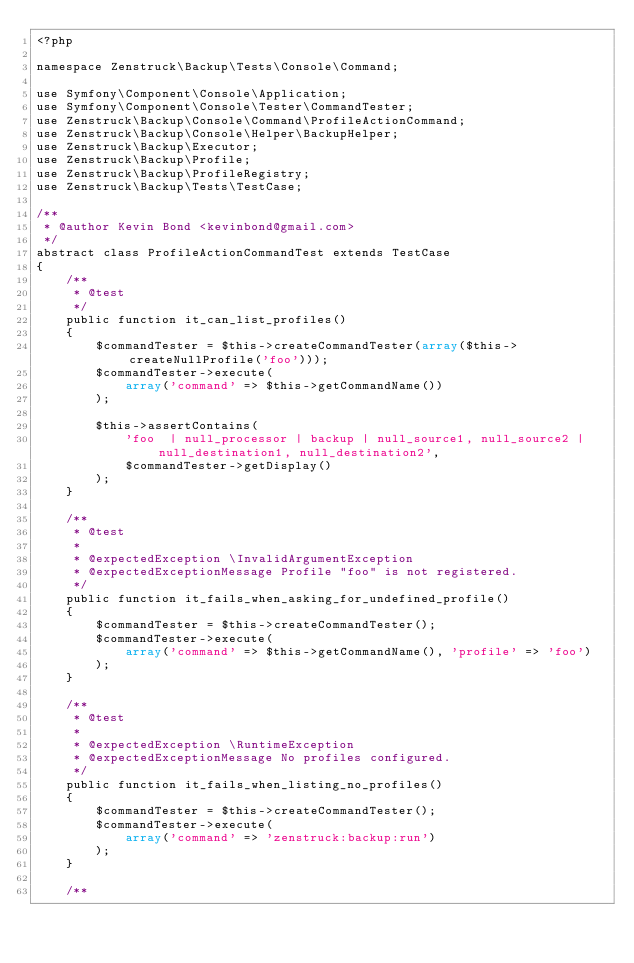Convert code to text. <code><loc_0><loc_0><loc_500><loc_500><_PHP_><?php

namespace Zenstruck\Backup\Tests\Console\Command;

use Symfony\Component\Console\Application;
use Symfony\Component\Console\Tester\CommandTester;
use Zenstruck\Backup\Console\Command\ProfileActionCommand;
use Zenstruck\Backup\Console\Helper\BackupHelper;
use Zenstruck\Backup\Executor;
use Zenstruck\Backup\Profile;
use Zenstruck\Backup\ProfileRegistry;
use Zenstruck\Backup\Tests\TestCase;

/**
 * @author Kevin Bond <kevinbond@gmail.com>
 */
abstract class ProfileActionCommandTest extends TestCase
{
    /**
     * @test
     */
    public function it_can_list_profiles()
    {
        $commandTester = $this->createCommandTester(array($this->createNullProfile('foo')));
        $commandTester->execute(
            array('command' => $this->getCommandName())
        );

        $this->assertContains(
            'foo  | null_processor | backup | null_source1, null_source2 | null_destination1, null_destination2',
            $commandTester->getDisplay()
        );
    }

    /**
     * @test
     *
     * @expectedException \InvalidArgumentException
     * @expectedExceptionMessage Profile "foo" is not registered.
     */
    public function it_fails_when_asking_for_undefined_profile()
    {
        $commandTester = $this->createCommandTester();
        $commandTester->execute(
            array('command' => $this->getCommandName(), 'profile' => 'foo')
        );
    }

    /**
     * @test
     *
     * @expectedException \RuntimeException
     * @expectedExceptionMessage No profiles configured.
     */
    public function it_fails_when_listing_no_profiles()
    {
        $commandTester = $this->createCommandTester();
        $commandTester->execute(
            array('command' => 'zenstruck:backup:run')
        );
    }

    /**</code> 